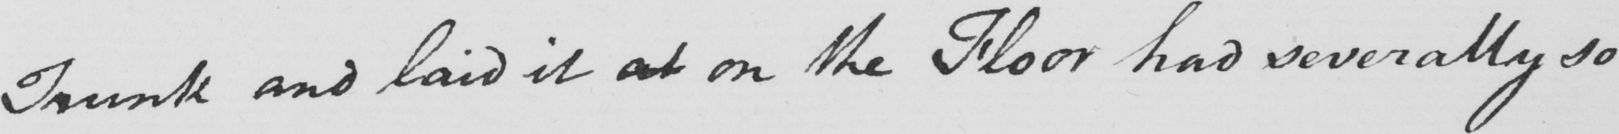What text is written in this handwritten line? Trunk and laid it at on the Floor had severally so 